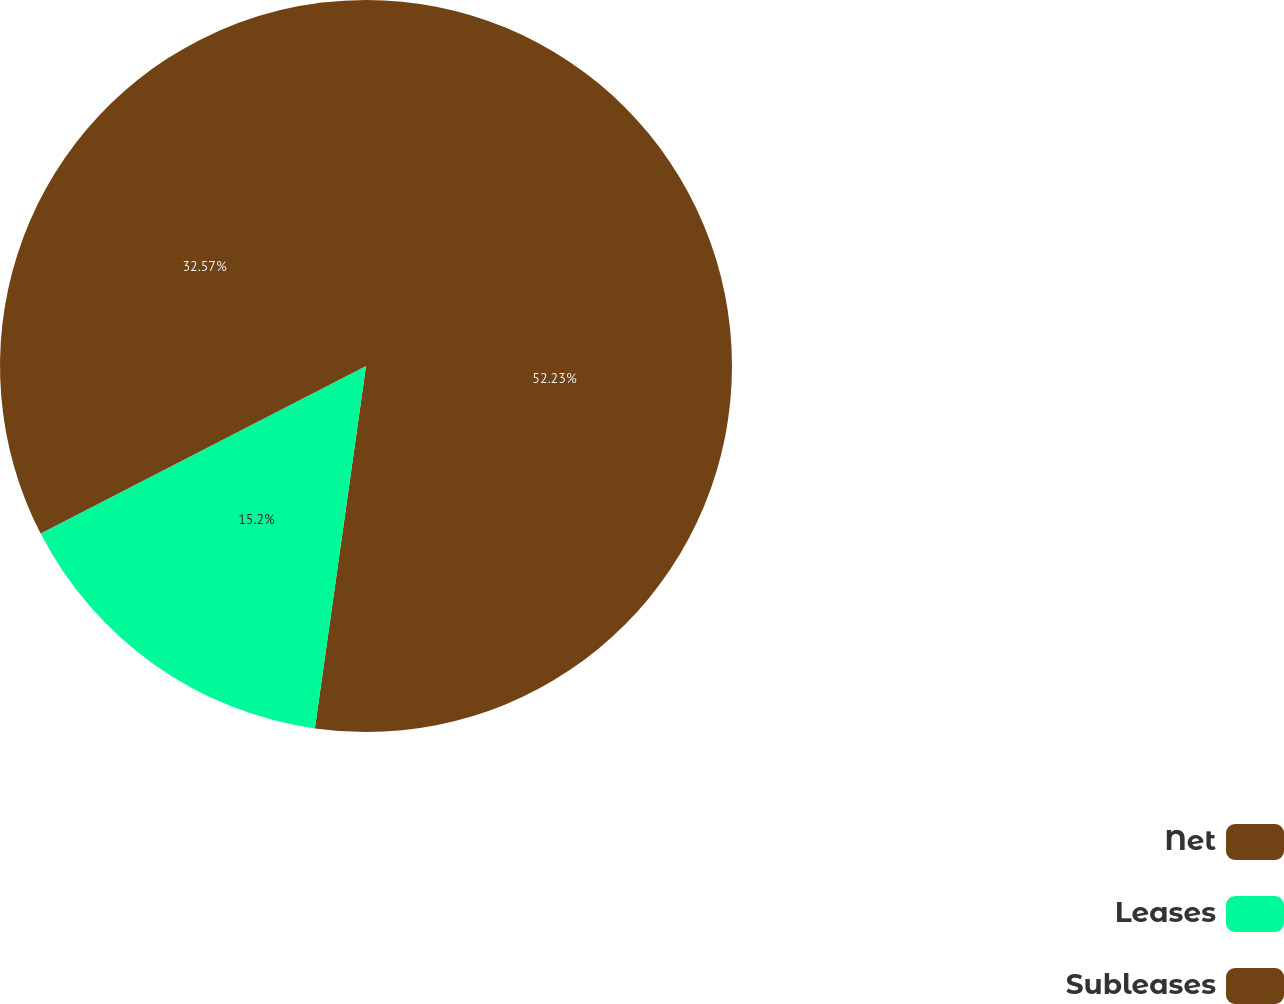Convert chart to OTSL. <chart><loc_0><loc_0><loc_500><loc_500><pie_chart><fcel>Net<fcel>Leases<fcel>Subleases<nl><fcel>52.23%<fcel>15.2%<fcel>32.57%<nl></chart> 